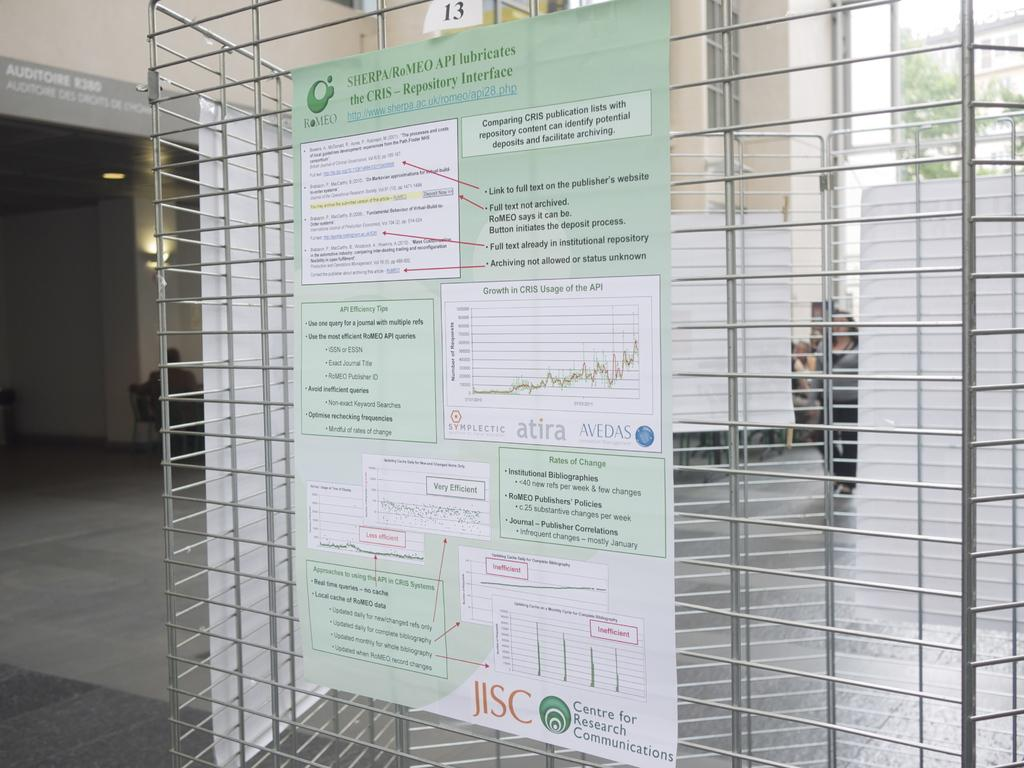<image>
Present a compact description of the photo's key features. wire shelving with a poster board for sherpa/romeo api 